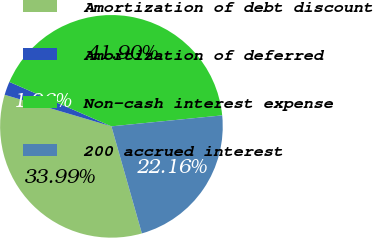<chart> <loc_0><loc_0><loc_500><loc_500><pie_chart><fcel>Amortization of debt discount<fcel>Amortization of deferred<fcel>Non-cash interest expense<fcel>200 accrued interest<nl><fcel>33.99%<fcel>1.96%<fcel>41.9%<fcel>22.16%<nl></chart> 